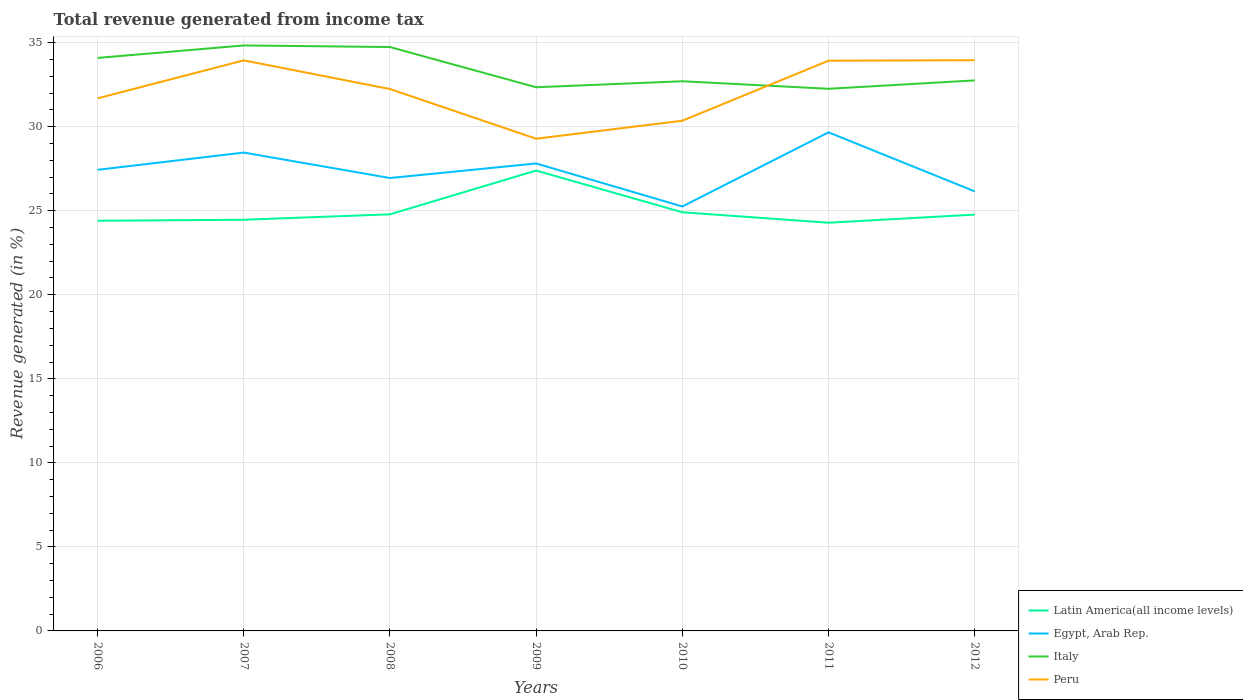Does the line corresponding to Egypt, Arab Rep. intersect with the line corresponding to Peru?
Keep it short and to the point. No. Is the number of lines equal to the number of legend labels?
Your response must be concise. Yes. Across all years, what is the maximum total revenue generated in Italy?
Your answer should be compact. 32.26. What is the total total revenue generated in Latin America(all income levels) in the graph?
Offer a terse response. -0.06. What is the difference between the highest and the second highest total revenue generated in Italy?
Offer a very short reply. 2.58. What is the difference between the highest and the lowest total revenue generated in Egypt, Arab Rep.?
Keep it short and to the point. 4. How many lines are there?
Your answer should be compact. 4. What is the difference between two consecutive major ticks on the Y-axis?
Keep it short and to the point. 5. Does the graph contain grids?
Your answer should be compact. Yes. Where does the legend appear in the graph?
Your answer should be compact. Bottom right. What is the title of the graph?
Your response must be concise. Total revenue generated from income tax. What is the label or title of the Y-axis?
Ensure brevity in your answer.  Revenue generated (in %). What is the Revenue generated (in %) of Latin America(all income levels) in 2006?
Provide a succinct answer. 24.41. What is the Revenue generated (in %) in Egypt, Arab Rep. in 2006?
Provide a short and direct response. 27.44. What is the Revenue generated (in %) in Italy in 2006?
Offer a very short reply. 34.09. What is the Revenue generated (in %) of Peru in 2006?
Your response must be concise. 31.69. What is the Revenue generated (in %) of Latin America(all income levels) in 2007?
Your answer should be very brief. 24.47. What is the Revenue generated (in %) of Egypt, Arab Rep. in 2007?
Provide a short and direct response. 28.46. What is the Revenue generated (in %) of Italy in 2007?
Provide a succinct answer. 34.84. What is the Revenue generated (in %) of Peru in 2007?
Keep it short and to the point. 33.95. What is the Revenue generated (in %) in Latin America(all income levels) in 2008?
Offer a terse response. 24.79. What is the Revenue generated (in %) in Egypt, Arab Rep. in 2008?
Provide a succinct answer. 26.95. What is the Revenue generated (in %) in Italy in 2008?
Keep it short and to the point. 34.74. What is the Revenue generated (in %) in Peru in 2008?
Offer a terse response. 32.24. What is the Revenue generated (in %) in Latin America(all income levels) in 2009?
Your response must be concise. 27.39. What is the Revenue generated (in %) in Egypt, Arab Rep. in 2009?
Give a very brief answer. 27.81. What is the Revenue generated (in %) in Italy in 2009?
Keep it short and to the point. 32.35. What is the Revenue generated (in %) of Peru in 2009?
Offer a terse response. 29.29. What is the Revenue generated (in %) of Latin America(all income levels) in 2010?
Your response must be concise. 24.91. What is the Revenue generated (in %) of Egypt, Arab Rep. in 2010?
Your answer should be compact. 25.26. What is the Revenue generated (in %) in Italy in 2010?
Provide a short and direct response. 32.71. What is the Revenue generated (in %) in Peru in 2010?
Ensure brevity in your answer.  30.36. What is the Revenue generated (in %) of Latin America(all income levels) in 2011?
Ensure brevity in your answer.  24.29. What is the Revenue generated (in %) in Egypt, Arab Rep. in 2011?
Your answer should be very brief. 29.67. What is the Revenue generated (in %) of Italy in 2011?
Keep it short and to the point. 32.26. What is the Revenue generated (in %) in Peru in 2011?
Keep it short and to the point. 33.93. What is the Revenue generated (in %) in Latin America(all income levels) in 2012?
Keep it short and to the point. 24.77. What is the Revenue generated (in %) of Egypt, Arab Rep. in 2012?
Your answer should be very brief. 26.15. What is the Revenue generated (in %) of Italy in 2012?
Keep it short and to the point. 32.76. What is the Revenue generated (in %) of Peru in 2012?
Give a very brief answer. 33.96. Across all years, what is the maximum Revenue generated (in %) of Latin America(all income levels)?
Your answer should be compact. 27.39. Across all years, what is the maximum Revenue generated (in %) in Egypt, Arab Rep.?
Your response must be concise. 29.67. Across all years, what is the maximum Revenue generated (in %) of Italy?
Provide a succinct answer. 34.84. Across all years, what is the maximum Revenue generated (in %) of Peru?
Ensure brevity in your answer.  33.96. Across all years, what is the minimum Revenue generated (in %) of Latin America(all income levels)?
Offer a terse response. 24.29. Across all years, what is the minimum Revenue generated (in %) in Egypt, Arab Rep.?
Offer a terse response. 25.26. Across all years, what is the minimum Revenue generated (in %) of Italy?
Offer a terse response. 32.26. Across all years, what is the minimum Revenue generated (in %) in Peru?
Keep it short and to the point. 29.29. What is the total Revenue generated (in %) in Latin America(all income levels) in the graph?
Provide a short and direct response. 175.02. What is the total Revenue generated (in %) in Egypt, Arab Rep. in the graph?
Offer a very short reply. 191.74. What is the total Revenue generated (in %) of Italy in the graph?
Keep it short and to the point. 233.74. What is the total Revenue generated (in %) of Peru in the graph?
Provide a succinct answer. 225.41. What is the difference between the Revenue generated (in %) of Latin America(all income levels) in 2006 and that in 2007?
Your answer should be very brief. -0.06. What is the difference between the Revenue generated (in %) of Egypt, Arab Rep. in 2006 and that in 2007?
Your answer should be very brief. -1.03. What is the difference between the Revenue generated (in %) in Italy in 2006 and that in 2007?
Keep it short and to the point. -0.74. What is the difference between the Revenue generated (in %) in Peru in 2006 and that in 2007?
Make the answer very short. -2.26. What is the difference between the Revenue generated (in %) in Latin America(all income levels) in 2006 and that in 2008?
Make the answer very short. -0.38. What is the difference between the Revenue generated (in %) in Egypt, Arab Rep. in 2006 and that in 2008?
Offer a terse response. 0.49. What is the difference between the Revenue generated (in %) in Italy in 2006 and that in 2008?
Ensure brevity in your answer.  -0.65. What is the difference between the Revenue generated (in %) in Peru in 2006 and that in 2008?
Make the answer very short. -0.55. What is the difference between the Revenue generated (in %) of Latin America(all income levels) in 2006 and that in 2009?
Give a very brief answer. -2.99. What is the difference between the Revenue generated (in %) in Egypt, Arab Rep. in 2006 and that in 2009?
Make the answer very short. -0.38. What is the difference between the Revenue generated (in %) in Italy in 2006 and that in 2009?
Your response must be concise. 1.74. What is the difference between the Revenue generated (in %) in Peru in 2006 and that in 2009?
Make the answer very short. 2.4. What is the difference between the Revenue generated (in %) of Latin America(all income levels) in 2006 and that in 2010?
Your answer should be very brief. -0.5. What is the difference between the Revenue generated (in %) in Egypt, Arab Rep. in 2006 and that in 2010?
Your answer should be compact. 2.18. What is the difference between the Revenue generated (in %) of Italy in 2006 and that in 2010?
Ensure brevity in your answer.  1.39. What is the difference between the Revenue generated (in %) of Peru in 2006 and that in 2010?
Your response must be concise. 1.33. What is the difference between the Revenue generated (in %) in Latin America(all income levels) in 2006 and that in 2011?
Ensure brevity in your answer.  0.12. What is the difference between the Revenue generated (in %) of Egypt, Arab Rep. in 2006 and that in 2011?
Your response must be concise. -2.23. What is the difference between the Revenue generated (in %) of Italy in 2006 and that in 2011?
Give a very brief answer. 1.83. What is the difference between the Revenue generated (in %) in Peru in 2006 and that in 2011?
Ensure brevity in your answer.  -2.24. What is the difference between the Revenue generated (in %) of Latin America(all income levels) in 2006 and that in 2012?
Your response must be concise. -0.37. What is the difference between the Revenue generated (in %) in Egypt, Arab Rep. in 2006 and that in 2012?
Offer a very short reply. 1.28. What is the difference between the Revenue generated (in %) in Italy in 2006 and that in 2012?
Your response must be concise. 1.34. What is the difference between the Revenue generated (in %) of Peru in 2006 and that in 2012?
Your answer should be compact. -2.27. What is the difference between the Revenue generated (in %) in Latin America(all income levels) in 2007 and that in 2008?
Your response must be concise. -0.32. What is the difference between the Revenue generated (in %) in Egypt, Arab Rep. in 2007 and that in 2008?
Your response must be concise. 1.51. What is the difference between the Revenue generated (in %) in Italy in 2007 and that in 2008?
Offer a very short reply. 0.1. What is the difference between the Revenue generated (in %) in Peru in 2007 and that in 2008?
Give a very brief answer. 1.71. What is the difference between the Revenue generated (in %) of Latin America(all income levels) in 2007 and that in 2009?
Your answer should be very brief. -2.93. What is the difference between the Revenue generated (in %) in Egypt, Arab Rep. in 2007 and that in 2009?
Offer a very short reply. 0.65. What is the difference between the Revenue generated (in %) of Italy in 2007 and that in 2009?
Offer a terse response. 2.49. What is the difference between the Revenue generated (in %) in Peru in 2007 and that in 2009?
Make the answer very short. 4.66. What is the difference between the Revenue generated (in %) of Latin America(all income levels) in 2007 and that in 2010?
Offer a terse response. -0.44. What is the difference between the Revenue generated (in %) in Egypt, Arab Rep. in 2007 and that in 2010?
Give a very brief answer. 3.21. What is the difference between the Revenue generated (in %) of Italy in 2007 and that in 2010?
Keep it short and to the point. 2.13. What is the difference between the Revenue generated (in %) in Peru in 2007 and that in 2010?
Ensure brevity in your answer.  3.59. What is the difference between the Revenue generated (in %) of Latin America(all income levels) in 2007 and that in 2011?
Make the answer very short. 0.18. What is the difference between the Revenue generated (in %) of Egypt, Arab Rep. in 2007 and that in 2011?
Give a very brief answer. -1.2. What is the difference between the Revenue generated (in %) of Italy in 2007 and that in 2011?
Provide a short and direct response. 2.58. What is the difference between the Revenue generated (in %) in Peru in 2007 and that in 2011?
Ensure brevity in your answer.  0.02. What is the difference between the Revenue generated (in %) in Latin America(all income levels) in 2007 and that in 2012?
Offer a terse response. -0.31. What is the difference between the Revenue generated (in %) of Egypt, Arab Rep. in 2007 and that in 2012?
Give a very brief answer. 2.31. What is the difference between the Revenue generated (in %) of Italy in 2007 and that in 2012?
Ensure brevity in your answer.  2.08. What is the difference between the Revenue generated (in %) in Peru in 2007 and that in 2012?
Make the answer very short. -0.01. What is the difference between the Revenue generated (in %) in Latin America(all income levels) in 2008 and that in 2009?
Keep it short and to the point. -2.61. What is the difference between the Revenue generated (in %) in Egypt, Arab Rep. in 2008 and that in 2009?
Your answer should be compact. -0.86. What is the difference between the Revenue generated (in %) of Italy in 2008 and that in 2009?
Your answer should be very brief. 2.39. What is the difference between the Revenue generated (in %) in Peru in 2008 and that in 2009?
Provide a succinct answer. 2.96. What is the difference between the Revenue generated (in %) of Latin America(all income levels) in 2008 and that in 2010?
Ensure brevity in your answer.  -0.12. What is the difference between the Revenue generated (in %) in Egypt, Arab Rep. in 2008 and that in 2010?
Your answer should be compact. 1.69. What is the difference between the Revenue generated (in %) of Italy in 2008 and that in 2010?
Give a very brief answer. 2.04. What is the difference between the Revenue generated (in %) of Peru in 2008 and that in 2010?
Offer a terse response. 1.89. What is the difference between the Revenue generated (in %) of Latin America(all income levels) in 2008 and that in 2011?
Your response must be concise. 0.5. What is the difference between the Revenue generated (in %) in Egypt, Arab Rep. in 2008 and that in 2011?
Your answer should be compact. -2.72. What is the difference between the Revenue generated (in %) of Italy in 2008 and that in 2011?
Make the answer very short. 2.48. What is the difference between the Revenue generated (in %) of Peru in 2008 and that in 2011?
Your answer should be compact. -1.69. What is the difference between the Revenue generated (in %) in Latin America(all income levels) in 2008 and that in 2012?
Provide a short and direct response. 0.02. What is the difference between the Revenue generated (in %) of Egypt, Arab Rep. in 2008 and that in 2012?
Provide a succinct answer. 0.79. What is the difference between the Revenue generated (in %) in Italy in 2008 and that in 2012?
Provide a succinct answer. 1.99. What is the difference between the Revenue generated (in %) in Peru in 2008 and that in 2012?
Your answer should be compact. -1.72. What is the difference between the Revenue generated (in %) in Latin America(all income levels) in 2009 and that in 2010?
Offer a very short reply. 2.48. What is the difference between the Revenue generated (in %) in Egypt, Arab Rep. in 2009 and that in 2010?
Provide a short and direct response. 2.56. What is the difference between the Revenue generated (in %) in Italy in 2009 and that in 2010?
Offer a very short reply. -0.36. What is the difference between the Revenue generated (in %) of Peru in 2009 and that in 2010?
Your answer should be very brief. -1.07. What is the difference between the Revenue generated (in %) of Latin America(all income levels) in 2009 and that in 2011?
Keep it short and to the point. 3.1. What is the difference between the Revenue generated (in %) of Egypt, Arab Rep. in 2009 and that in 2011?
Provide a short and direct response. -1.85. What is the difference between the Revenue generated (in %) in Italy in 2009 and that in 2011?
Offer a terse response. 0.09. What is the difference between the Revenue generated (in %) of Peru in 2009 and that in 2011?
Offer a very short reply. -4.64. What is the difference between the Revenue generated (in %) in Latin America(all income levels) in 2009 and that in 2012?
Your response must be concise. 2.62. What is the difference between the Revenue generated (in %) of Egypt, Arab Rep. in 2009 and that in 2012?
Offer a terse response. 1.66. What is the difference between the Revenue generated (in %) in Italy in 2009 and that in 2012?
Keep it short and to the point. -0.41. What is the difference between the Revenue generated (in %) in Peru in 2009 and that in 2012?
Ensure brevity in your answer.  -4.67. What is the difference between the Revenue generated (in %) of Latin America(all income levels) in 2010 and that in 2011?
Your answer should be compact. 0.62. What is the difference between the Revenue generated (in %) in Egypt, Arab Rep. in 2010 and that in 2011?
Keep it short and to the point. -4.41. What is the difference between the Revenue generated (in %) of Italy in 2010 and that in 2011?
Offer a very short reply. 0.45. What is the difference between the Revenue generated (in %) in Peru in 2010 and that in 2011?
Make the answer very short. -3.57. What is the difference between the Revenue generated (in %) of Latin America(all income levels) in 2010 and that in 2012?
Your answer should be compact. 0.14. What is the difference between the Revenue generated (in %) of Egypt, Arab Rep. in 2010 and that in 2012?
Offer a very short reply. -0.9. What is the difference between the Revenue generated (in %) in Italy in 2010 and that in 2012?
Offer a very short reply. -0.05. What is the difference between the Revenue generated (in %) in Peru in 2010 and that in 2012?
Your answer should be very brief. -3.6. What is the difference between the Revenue generated (in %) in Latin America(all income levels) in 2011 and that in 2012?
Make the answer very short. -0.48. What is the difference between the Revenue generated (in %) in Egypt, Arab Rep. in 2011 and that in 2012?
Your answer should be very brief. 3.51. What is the difference between the Revenue generated (in %) of Italy in 2011 and that in 2012?
Your answer should be compact. -0.5. What is the difference between the Revenue generated (in %) of Peru in 2011 and that in 2012?
Make the answer very short. -0.03. What is the difference between the Revenue generated (in %) of Latin America(all income levels) in 2006 and the Revenue generated (in %) of Egypt, Arab Rep. in 2007?
Provide a succinct answer. -4.06. What is the difference between the Revenue generated (in %) of Latin America(all income levels) in 2006 and the Revenue generated (in %) of Italy in 2007?
Your response must be concise. -10.43. What is the difference between the Revenue generated (in %) of Latin America(all income levels) in 2006 and the Revenue generated (in %) of Peru in 2007?
Provide a succinct answer. -9.54. What is the difference between the Revenue generated (in %) of Egypt, Arab Rep. in 2006 and the Revenue generated (in %) of Italy in 2007?
Your answer should be very brief. -7.4. What is the difference between the Revenue generated (in %) in Egypt, Arab Rep. in 2006 and the Revenue generated (in %) in Peru in 2007?
Give a very brief answer. -6.51. What is the difference between the Revenue generated (in %) in Italy in 2006 and the Revenue generated (in %) in Peru in 2007?
Make the answer very short. 0.14. What is the difference between the Revenue generated (in %) in Latin America(all income levels) in 2006 and the Revenue generated (in %) in Egypt, Arab Rep. in 2008?
Give a very brief answer. -2.54. What is the difference between the Revenue generated (in %) in Latin America(all income levels) in 2006 and the Revenue generated (in %) in Italy in 2008?
Offer a very short reply. -10.34. What is the difference between the Revenue generated (in %) of Latin America(all income levels) in 2006 and the Revenue generated (in %) of Peru in 2008?
Ensure brevity in your answer.  -7.84. What is the difference between the Revenue generated (in %) of Egypt, Arab Rep. in 2006 and the Revenue generated (in %) of Italy in 2008?
Your answer should be very brief. -7.31. What is the difference between the Revenue generated (in %) in Egypt, Arab Rep. in 2006 and the Revenue generated (in %) in Peru in 2008?
Make the answer very short. -4.81. What is the difference between the Revenue generated (in %) of Italy in 2006 and the Revenue generated (in %) of Peru in 2008?
Offer a terse response. 1.85. What is the difference between the Revenue generated (in %) of Latin America(all income levels) in 2006 and the Revenue generated (in %) of Egypt, Arab Rep. in 2009?
Offer a very short reply. -3.41. What is the difference between the Revenue generated (in %) of Latin America(all income levels) in 2006 and the Revenue generated (in %) of Italy in 2009?
Ensure brevity in your answer.  -7.94. What is the difference between the Revenue generated (in %) in Latin America(all income levels) in 2006 and the Revenue generated (in %) in Peru in 2009?
Ensure brevity in your answer.  -4.88. What is the difference between the Revenue generated (in %) in Egypt, Arab Rep. in 2006 and the Revenue generated (in %) in Italy in 2009?
Your response must be concise. -4.91. What is the difference between the Revenue generated (in %) of Egypt, Arab Rep. in 2006 and the Revenue generated (in %) of Peru in 2009?
Ensure brevity in your answer.  -1.85. What is the difference between the Revenue generated (in %) of Italy in 2006 and the Revenue generated (in %) of Peru in 2009?
Offer a terse response. 4.81. What is the difference between the Revenue generated (in %) of Latin America(all income levels) in 2006 and the Revenue generated (in %) of Egypt, Arab Rep. in 2010?
Offer a very short reply. -0.85. What is the difference between the Revenue generated (in %) of Latin America(all income levels) in 2006 and the Revenue generated (in %) of Peru in 2010?
Give a very brief answer. -5.95. What is the difference between the Revenue generated (in %) in Egypt, Arab Rep. in 2006 and the Revenue generated (in %) in Italy in 2010?
Provide a short and direct response. -5.27. What is the difference between the Revenue generated (in %) in Egypt, Arab Rep. in 2006 and the Revenue generated (in %) in Peru in 2010?
Your answer should be compact. -2.92. What is the difference between the Revenue generated (in %) of Italy in 2006 and the Revenue generated (in %) of Peru in 2010?
Keep it short and to the point. 3.74. What is the difference between the Revenue generated (in %) of Latin America(all income levels) in 2006 and the Revenue generated (in %) of Egypt, Arab Rep. in 2011?
Ensure brevity in your answer.  -5.26. What is the difference between the Revenue generated (in %) in Latin America(all income levels) in 2006 and the Revenue generated (in %) in Italy in 2011?
Offer a terse response. -7.85. What is the difference between the Revenue generated (in %) of Latin America(all income levels) in 2006 and the Revenue generated (in %) of Peru in 2011?
Your answer should be very brief. -9.52. What is the difference between the Revenue generated (in %) of Egypt, Arab Rep. in 2006 and the Revenue generated (in %) of Italy in 2011?
Provide a short and direct response. -4.82. What is the difference between the Revenue generated (in %) of Egypt, Arab Rep. in 2006 and the Revenue generated (in %) of Peru in 2011?
Your answer should be compact. -6.49. What is the difference between the Revenue generated (in %) of Italy in 2006 and the Revenue generated (in %) of Peru in 2011?
Keep it short and to the point. 0.16. What is the difference between the Revenue generated (in %) of Latin America(all income levels) in 2006 and the Revenue generated (in %) of Egypt, Arab Rep. in 2012?
Make the answer very short. -1.75. What is the difference between the Revenue generated (in %) in Latin America(all income levels) in 2006 and the Revenue generated (in %) in Italy in 2012?
Your answer should be compact. -8.35. What is the difference between the Revenue generated (in %) of Latin America(all income levels) in 2006 and the Revenue generated (in %) of Peru in 2012?
Your answer should be compact. -9.55. What is the difference between the Revenue generated (in %) in Egypt, Arab Rep. in 2006 and the Revenue generated (in %) in Italy in 2012?
Ensure brevity in your answer.  -5.32. What is the difference between the Revenue generated (in %) in Egypt, Arab Rep. in 2006 and the Revenue generated (in %) in Peru in 2012?
Offer a terse response. -6.52. What is the difference between the Revenue generated (in %) in Italy in 2006 and the Revenue generated (in %) in Peru in 2012?
Provide a short and direct response. 0.13. What is the difference between the Revenue generated (in %) in Latin America(all income levels) in 2007 and the Revenue generated (in %) in Egypt, Arab Rep. in 2008?
Give a very brief answer. -2.48. What is the difference between the Revenue generated (in %) of Latin America(all income levels) in 2007 and the Revenue generated (in %) of Italy in 2008?
Give a very brief answer. -10.28. What is the difference between the Revenue generated (in %) of Latin America(all income levels) in 2007 and the Revenue generated (in %) of Peru in 2008?
Provide a succinct answer. -7.78. What is the difference between the Revenue generated (in %) of Egypt, Arab Rep. in 2007 and the Revenue generated (in %) of Italy in 2008?
Make the answer very short. -6.28. What is the difference between the Revenue generated (in %) in Egypt, Arab Rep. in 2007 and the Revenue generated (in %) in Peru in 2008?
Your answer should be compact. -3.78. What is the difference between the Revenue generated (in %) in Italy in 2007 and the Revenue generated (in %) in Peru in 2008?
Provide a succinct answer. 2.59. What is the difference between the Revenue generated (in %) in Latin America(all income levels) in 2007 and the Revenue generated (in %) in Egypt, Arab Rep. in 2009?
Your response must be concise. -3.35. What is the difference between the Revenue generated (in %) of Latin America(all income levels) in 2007 and the Revenue generated (in %) of Italy in 2009?
Provide a succinct answer. -7.88. What is the difference between the Revenue generated (in %) of Latin America(all income levels) in 2007 and the Revenue generated (in %) of Peru in 2009?
Offer a very short reply. -4.82. What is the difference between the Revenue generated (in %) of Egypt, Arab Rep. in 2007 and the Revenue generated (in %) of Italy in 2009?
Offer a very short reply. -3.89. What is the difference between the Revenue generated (in %) in Egypt, Arab Rep. in 2007 and the Revenue generated (in %) in Peru in 2009?
Provide a succinct answer. -0.82. What is the difference between the Revenue generated (in %) of Italy in 2007 and the Revenue generated (in %) of Peru in 2009?
Your response must be concise. 5.55. What is the difference between the Revenue generated (in %) in Latin America(all income levels) in 2007 and the Revenue generated (in %) in Egypt, Arab Rep. in 2010?
Provide a short and direct response. -0.79. What is the difference between the Revenue generated (in %) in Latin America(all income levels) in 2007 and the Revenue generated (in %) in Italy in 2010?
Make the answer very short. -8.24. What is the difference between the Revenue generated (in %) in Latin America(all income levels) in 2007 and the Revenue generated (in %) in Peru in 2010?
Provide a succinct answer. -5.89. What is the difference between the Revenue generated (in %) of Egypt, Arab Rep. in 2007 and the Revenue generated (in %) of Italy in 2010?
Your answer should be compact. -4.24. What is the difference between the Revenue generated (in %) of Egypt, Arab Rep. in 2007 and the Revenue generated (in %) of Peru in 2010?
Provide a succinct answer. -1.89. What is the difference between the Revenue generated (in %) in Italy in 2007 and the Revenue generated (in %) in Peru in 2010?
Keep it short and to the point. 4.48. What is the difference between the Revenue generated (in %) in Latin America(all income levels) in 2007 and the Revenue generated (in %) in Egypt, Arab Rep. in 2011?
Offer a terse response. -5.2. What is the difference between the Revenue generated (in %) of Latin America(all income levels) in 2007 and the Revenue generated (in %) of Italy in 2011?
Your answer should be very brief. -7.79. What is the difference between the Revenue generated (in %) in Latin America(all income levels) in 2007 and the Revenue generated (in %) in Peru in 2011?
Offer a terse response. -9.46. What is the difference between the Revenue generated (in %) of Egypt, Arab Rep. in 2007 and the Revenue generated (in %) of Italy in 2011?
Offer a terse response. -3.8. What is the difference between the Revenue generated (in %) in Egypt, Arab Rep. in 2007 and the Revenue generated (in %) in Peru in 2011?
Make the answer very short. -5.47. What is the difference between the Revenue generated (in %) in Italy in 2007 and the Revenue generated (in %) in Peru in 2011?
Keep it short and to the point. 0.91. What is the difference between the Revenue generated (in %) in Latin America(all income levels) in 2007 and the Revenue generated (in %) in Egypt, Arab Rep. in 2012?
Your answer should be compact. -1.69. What is the difference between the Revenue generated (in %) in Latin America(all income levels) in 2007 and the Revenue generated (in %) in Italy in 2012?
Offer a very short reply. -8.29. What is the difference between the Revenue generated (in %) of Latin America(all income levels) in 2007 and the Revenue generated (in %) of Peru in 2012?
Your response must be concise. -9.49. What is the difference between the Revenue generated (in %) of Egypt, Arab Rep. in 2007 and the Revenue generated (in %) of Italy in 2012?
Offer a terse response. -4.29. What is the difference between the Revenue generated (in %) of Egypt, Arab Rep. in 2007 and the Revenue generated (in %) of Peru in 2012?
Your response must be concise. -5.5. What is the difference between the Revenue generated (in %) in Italy in 2007 and the Revenue generated (in %) in Peru in 2012?
Provide a succinct answer. 0.88. What is the difference between the Revenue generated (in %) of Latin America(all income levels) in 2008 and the Revenue generated (in %) of Egypt, Arab Rep. in 2009?
Provide a succinct answer. -3.03. What is the difference between the Revenue generated (in %) of Latin America(all income levels) in 2008 and the Revenue generated (in %) of Italy in 2009?
Your answer should be compact. -7.56. What is the difference between the Revenue generated (in %) of Latin America(all income levels) in 2008 and the Revenue generated (in %) of Peru in 2009?
Offer a terse response. -4.5. What is the difference between the Revenue generated (in %) in Egypt, Arab Rep. in 2008 and the Revenue generated (in %) in Peru in 2009?
Ensure brevity in your answer.  -2.34. What is the difference between the Revenue generated (in %) in Italy in 2008 and the Revenue generated (in %) in Peru in 2009?
Keep it short and to the point. 5.46. What is the difference between the Revenue generated (in %) in Latin America(all income levels) in 2008 and the Revenue generated (in %) in Egypt, Arab Rep. in 2010?
Keep it short and to the point. -0.47. What is the difference between the Revenue generated (in %) of Latin America(all income levels) in 2008 and the Revenue generated (in %) of Italy in 2010?
Provide a short and direct response. -7.92. What is the difference between the Revenue generated (in %) of Latin America(all income levels) in 2008 and the Revenue generated (in %) of Peru in 2010?
Offer a very short reply. -5.57. What is the difference between the Revenue generated (in %) of Egypt, Arab Rep. in 2008 and the Revenue generated (in %) of Italy in 2010?
Provide a succinct answer. -5.76. What is the difference between the Revenue generated (in %) of Egypt, Arab Rep. in 2008 and the Revenue generated (in %) of Peru in 2010?
Offer a terse response. -3.41. What is the difference between the Revenue generated (in %) in Italy in 2008 and the Revenue generated (in %) in Peru in 2010?
Your response must be concise. 4.38. What is the difference between the Revenue generated (in %) of Latin America(all income levels) in 2008 and the Revenue generated (in %) of Egypt, Arab Rep. in 2011?
Offer a terse response. -4.88. What is the difference between the Revenue generated (in %) in Latin America(all income levels) in 2008 and the Revenue generated (in %) in Italy in 2011?
Make the answer very short. -7.47. What is the difference between the Revenue generated (in %) of Latin America(all income levels) in 2008 and the Revenue generated (in %) of Peru in 2011?
Make the answer very short. -9.14. What is the difference between the Revenue generated (in %) of Egypt, Arab Rep. in 2008 and the Revenue generated (in %) of Italy in 2011?
Offer a terse response. -5.31. What is the difference between the Revenue generated (in %) in Egypt, Arab Rep. in 2008 and the Revenue generated (in %) in Peru in 2011?
Your answer should be very brief. -6.98. What is the difference between the Revenue generated (in %) of Italy in 2008 and the Revenue generated (in %) of Peru in 2011?
Your answer should be very brief. 0.81. What is the difference between the Revenue generated (in %) in Latin America(all income levels) in 2008 and the Revenue generated (in %) in Egypt, Arab Rep. in 2012?
Provide a succinct answer. -1.37. What is the difference between the Revenue generated (in %) in Latin America(all income levels) in 2008 and the Revenue generated (in %) in Italy in 2012?
Keep it short and to the point. -7.97. What is the difference between the Revenue generated (in %) in Latin America(all income levels) in 2008 and the Revenue generated (in %) in Peru in 2012?
Offer a very short reply. -9.17. What is the difference between the Revenue generated (in %) of Egypt, Arab Rep. in 2008 and the Revenue generated (in %) of Italy in 2012?
Give a very brief answer. -5.81. What is the difference between the Revenue generated (in %) in Egypt, Arab Rep. in 2008 and the Revenue generated (in %) in Peru in 2012?
Offer a very short reply. -7.01. What is the difference between the Revenue generated (in %) in Italy in 2008 and the Revenue generated (in %) in Peru in 2012?
Ensure brevity in your answer.  0.78. What is the difference between the Revenue generated (in %) of Latin America(all income levels) in 2009 and the Revenue generated (in %) of Egypt, Arab Rep. in 2010?
Offer a very short reply. 2.14. What is the difference between the Revenue generated (in %) of Latin America(all income levels) in 2009 and the Revenue generated (in %) of Italy in 2010?
Your answer should be very brief. -5.31. What is the difference between the Revenue generated (in %) of Latin America(all income levels) in 2009 and the Revenue generated (in %) of Peru in 2010?
Your answer should be compact. -2.96. What is the difference between the Revenue generated (in %) in Egypt, Arab Rep. in 2009 and the Revenue generated (in %) in Italy in 2010?
Offer a very short reply. -4.89. What is the difference between the Revenue generated (in %) of Egypt, Arab Rep. in 2009 and the Revenue generated (in %) of Peru in 2010?
Your answer should be very brief. -2.54. What is the difference between the Revenue generated (in %) of Italy in 2009 and the Revenue generated (in %) of Peru in 2010?
Provide a succinct answer. 1.99. What is the difference between the Revenue generated (in %) in Latin America(all income levels) in 2009 and the Revenue generated (in %) in Egypt, Arab Rep. in 2011?
Provide a short and direct response. -2.27. What is the difference between the Revenue generated (in %) of Latin America(all income levels) in 2009 and the Revenue generated (in %) of Italy in 2011?
Your response must be concise. -4.87. What is the difference between the Revenue generated (in %) of Latin America(all income levels) in 2009 and the Revenue generated (in %) of Peru in 2011?
Your answer should be compact. -6.54. What is the difference between the Revenue generated (in %) of Egypt, Arab Rep. in 2009 and the Revenue generated (in %) of Italy in 2011?
Offer a very short reply. -4.44. What is the difference between the Revenue generated (in %) in Egypt, Arab Rep. in 2009 and the Revenue generated (in %) in Peru in 2011?
Your answer should be very brief. -6.12. What is the difference between the Revenue generated (in %) of Italy in 2009 and the Revenue generated (in %) of Peru in 2011?
Your answer should be very brief. -1.58. What is the difference between the Revenue generated (in %) of Latin America(all income levels) in 2009 and the Revenue generated (in %) of Egypt, Arab Rep. in 2012?
Provide a succinct answer. 1.24. What is the difference between the Revenue generated (in %) of Latin America(all income levels) in 2009 and the Revenue generated (in %) of Italy in 2012?
Offer a terse response. -5.36. What is the difference between the Revenue generated (in %) of Latin America(all income levels) in 2009 and the Revenue generated (in %) of Peru in 2012?
Make the answer very short. -6.57. What is the difference between the Revenue generated (in %) in Egypt, Arab Rep. in 2009 and the Revenue generated (in %) in Italy in 2012?
Offer a very short reply. -4.94. What is the difference between the Revenue generated (in %) in Egypt, Arab Rep. in 2009 and the Revenue generated (in %) in Peru in 2012?
Keep it short and to the point. -6.15. What is the difference between the Revenue generated (in %) of Italy in 2009 and the Revenue generated (in %) of Peru in 2012?
Your answer should be compact. -1.61. What is the difference between the Revenue generated (in %) in Latin America(all income levels) in 2010 and the Revenue generated (in %) in Egypt, Arab Rep. in 2011?
Offer a very short reply. -4.76. What is the difference between the Revenue generated (in %) in Latin America(all income levels) in 2010 and the Revenue generated (in %) in Italy in 2011?
Give a very brief answer. -7.35. What is the difference between the Revenue generated (in %) of Latin America(all income levels) in 2010 and the Revenue generated (in %) of Peru in 2011?
Your answer should be very brief. -9.02. What is the difference between the Revenue generated (in %) of Egypt, Arab Rep. in 2010 and the Revenue generated (in %) of Italy in 2011?
Your response must be concise. -7. What is the difference between the Revenue generated (in %) in Egypt, Arab Rep. in 2010 and the Revenue generated (in %) in Peru in 2011?
Provide a succinct answer. -8.67. What is the difference between the Revenue generated (in %) in Italy in 2010 and the Revenue generated (in %) in Peru in 2011?
Your answer should be compact. -1.22. What is the difference between the Revenue generated (in %) of Latin America(all income levels) in 2010 and the Revenue generated (in %) of Egypt, Arab Rep. in 2012?
Ensure brevity in your answer.  -1.24. What is the difference between the Revenue generated (in %) in Latin America(all income levels) in 2010 and the Revenue generated (in %) in Italy in 2012?
Your answer should be compact. -7.85. What is the difference between the Revenue generated (in %) of Latin America(all income levels) in 2010 and the Revenue generated (in %) of Peru in 2012?
Your response must be concise. -9.05. What is the difference between the Revenue generated (in %) of Egypt, Arab Rep. in 2010 and the Revenue generated (in %) of Italy in 2012?
Keep it short and to the point. -7.5. What is the difference between the Revenue generated (in %) of Egypt, Arab Rep. in 2010 and the Revenue generated (in %) of Peru in 2012?
Make the answer very short. -8.7. What is the difference between the Revenue generated (in %) in Italy in 2010 and the Revenue generated (in %) in Peru in 2012?
Offer a very short reply. -1.25. What is the difference between the Revenue generated (in %) of Latin America(all income levels) in 2011 and the Revenue generated (in %) of Egypt, Arab Rep. in 2012?
Your response must be concise. -1.87. What is the difference between the Revenue generated (in %) of Latin America(all income levels) in 2011 and the Revenue generated (in %) of Italy in 2012?
Your answer should be compact. -8.47. What is the difference between the Revenue generated (in %) in Latin America(all income levels) in 2011 and the Revenue generated (in %) in Peru in 2012?
Your answer should be very brief. -9.67. What is the difference between the Revenue generated (in %) of Egypt, Arab Rep. in 2011 and the Revenue generated (in %) of Italy in 2012?
Offer a terse response. -3.09. What is the difference between the Revenue generated (in %) in Egypt, Arab Rep. in 2011 and the Revenue generated (in %) in Peru in 2012?
Offer a very short reply. -4.29. What is the difference between the Revenue generated (in %) of Italy in 2011 and the Revenue generated (in %) of Peru in 2012?
Ensure brevity in your answer.  -1.7. What is the average Revenue generated (in %) in Latin America(all income levels) per year?
Make the answer very short. 25. What is the average Revenue generated (in %) of Egypt, Arab Rep. per year?
Offer a very short reply. 27.39. What is the average Revenue generated (in %) of Italy per year?
Offer a terse response. 33.39. What is the average Revenue generated (in %) in Peru per year?
Provide a succinct answer. 32.2. In the year 2006, what is the difference between the Revenue generated (in %) in Latin America(all income levels) and Revenue generated (in %) in Egypt, Arab Rep.?
Give a very brief answer. -3.03. In the year 2006, what is the difference between the Revenue generated (in %) of Latin America(all income levels) and Revenue generated (in %) of Italy?
Your answer should be very brief. -9.69. In the year 2006, what is the difference between the Revenue generated (in %) in Latin America(all income levels) and Revenue generated (in %) in Peru?
Offer a very short reply. -7.28. In the year 2006, what is the difference between the Revenue generated (in %) of Egypt, Arab Rep. and Revenue generated (in %) of Italy?
Your response must be concise. -6.66. In the year 2006, what is the difference between the Revenue generated (in %) of Egypt, Arab Rep. and Revenue generated (in %) of Peru?
Provide a short and direct response. -4.25. In the year 2006, what is the difference between the Revenue generated (in %) of Italy and Revenue generated (in %) of Peru?
Give a very brief answer. 2.4. In the year 2007, what is the difference between the Revenue generated (in %) of Latin America(all income levels) and Revenue generated (in %) of Egypt, Arab Rep.?
Provide a short and direct response. -4. In the year 2007, what is the difference between the Revenue generated (in %) in Latin America(all income levels) and Revenue generated (in %) in Italy?
Offer a very short reply. -10.37. In the year 2007, what is the difference between the Revenue generated (in %) in Latin America(all income levels) and Revenue generated (in %) in Peru?
Provide a succinct answer. -9.48. In the year 2007, what is the difference between the Revenue generated (in %) in Egypt, Arab Rep. and Revenue generated (in %) in Italy?
Offer a very short reply. -6.37. In the year 2007, what is the difference between the Revenue generated (in %) of Egypt, Arab Rep. and Revenue generated (in %) of Peru?
Give a very brief answer. -5.49. In the year 2007, what is the difference between the Revenue generated (in %) of Italy and Revenue generated (in %) of Peru?
Provide a succinct answer. 0.89. In the year 2008, what is the difference between the Revenue generated (in %) of Latin America(all income levels) and Revenue generated (in %) of Egypt, Arab Rep.?
Provide a succinct answer. -2.16. In the year 2008, what is the difference between the Revenue generated (in %) of Latin America(all income levels) and Revenue generated (in %) of Italy?
Provide a short and direct response. -9.95. In the year 2008, what is the difference between the Revenue generated (in %) of Latin America(all income levels) and Revenue generated (in %) of Peru?
Offer a terse response. -7.46. In the year 2008, what is the difference between the Revenue generated (in %) of Egypt, Arab Rep. and Revenue generated (in %) of Italy?
Offer a very short reply. -7.79. In the year 2008, what is the difference between the Revenue generated (in %) of Egypt, Arab Rep. and Revenue generated (in %) of Peru?
Ensure brevity in your answer.  -5.29. In the year 2008, what is the difference between the Revenue generated (in %) of Italy and Revenue generated (in %) of Peru?
Offer a very short reply. 2.5. In the year 2009, what is the difference between the Revenue generated (in %) in Latin America(all income levels) and Revenue generated (in %) in Egypt, Arab Rep.?
Offer a very short reply. -0.42. In the year 2009, what is the difference between the Revenue generated (in %) of Latin America(all income levels) and Revenue generated (in %) of Italy?
Ensure brevity in your answer.  -4.96. In the year 2009, what is the difference between the Revenue generated (in %) of Latin America(all income levels) and Revenue generated (in %) of Peru?
Provide a short and direct response. -1.89. In the year 2009, what is the difference between the Revenue generated (in %) of Egypt, Arab Rep. and Revenue generated (in %) of Italy?
Ensure brevity in your answer.  -4.54. In the year 2009, what is the difference between the Revenue generated (in %) in Egypt, Arab Rep. and Revenue generated (in %) in Peru?
Keep it short and to the point. -1.47. In the year 2009, what is the difference between the Revenue generated (in %) in Italy and Revenue generated (in %) in Peru?
Your response must be concise. 3.06. In the year 2010, what is the difference between the Revenue generated (in %) in Latin America(all income levels) and Revenue generated (in %) in Egypt, Arab Rep.?
Provide a short and direct response. -0.34. In the year 2010, what is the difference between the Revenue generated (in %) in Latin America(all income levels) and Revenue generated (in %) in Italy?
Offer a very short reply. -7.8. In the year 2010, what is the difference between the Revenue generated (in %) in Latin America(all income levels) and Revenue generated (in %) in Peru?
Provide a succinct answer. -5.45. In the year 2010, what is the difference between the Revenue generated (in %) in Egypt, Arab Rep. and Revenue generated (in %) in Italy?
Your response must be concise. -7.45. In the year 2010, what is the difference between the Revenue generated (in %) in Egypt, Arab Rep. and Revenue generated (in %) in Peru?
Your answer should be compact. -5.1. In the year 2010, what is the difference between the Revenue generated (in %) in Italy and Revenue generated (in %) in Peru?
Provide a short and direct response. 2.35. In the year 2011, what is the difference between the Revenue generated (in %) of Latin America(all income levels) and Revenue generated (in %) of Egypt, Arab Rep.?
Provide a succinct answer. -5.38. In the year 2011, what is the difference between the Revenue generated (in %) of Latin America(all income levels) and Revenue generated (in %) of Italy?
Your response must be concise. -7.97. In the year 2011, what is the difference between the Revenue generated (in %) in Latin America(all income levels) and Revenue generated (in %) in Peru?
Your response must be concise. -9.64. In the year 2011, what is the difference between the Revenue generated (in %) of Egypt, Arab Rep. and Revenue generated (in %) of Italy?
Provide a short and direct response. -2.59. In the year 2011, what is the difference between the Revenue generated (in %) in Egypt, Arab Rep. and Revenue generated (in %) in Peru?
Your answer should be compact. -4.26. In the year 2011, what is the difference between the Revenue generated (in %) in Italy and Revenue generated (in %) in Peru?
Your response must be concise. -1.67. In the year 2012, what is the difference between the Revenue generated (in %) of Latin America(all income levels) and Revenue generated (in %) of Egypt, Arab Rep.?
Your response must be concise. -1.38. In the year 2012, what is the difference between the Revenue generated (in %) of Latin America(all income levels) and Revenue generated (in %) of Italy?
Provide a succinct answer. -7.99. In the year 2012, what is the difference between the Revenue generated (in %) of Latin America(all income levels) and Revenue generated (in %) of Peru?
Keep it short and to the point. -9.19. In the year 2012, what is the difference between the Revenue generated (in %) in Egypt, Arab Rep. and Revenue generated (in %) in Italy?
Ensure brevity in your answer.  -6.6. In the year 2012, what is the difference between the Revenue generated (in %) in Egypt, Arab Rep. and Revenue generated (in %) in Peru?
Your answer should be very brief. -7.8. In the year 2012, what is the difference between the Revenue generated (in %) of Italy and Revenue generated (in %) of Peru?
Keep it short and to the point. -1.2. What is the ratio of the Revenue generated (in %) of Egypt, Arab Rep. in 2006 to that in 2007?
Offer a very short reply. 0.96. What is the ratio of the Revenue generated (in %) of Italy in 2006 to that in 2007?
Your answer should be very brief. 0.98. What is the ratio of the Revenue generated (in %) of Peru in 2006 to that in 2007?
Give a very brief answer. 0.93. What is the ratio of the Revenue generated (in %) of Latin America(all income levels) in 2006 to that in 2008?
Offer a very short reply. 0.98. What is the ratio of the Revenue generated (in %) in Egypt, Arab Rep. in 2006 to that in 2008?
Offer a very short reply. 1.02. What is the ratio of the Revenue generated (in %) in Italy in 2006 to that in 2008?
Your answer should be very brief. 0.98. What is the ratio of the Revenue generated (in %) of Peru in 2006 to that in 2008?
Offer a terse response. 0.98. What is the ratio of the Revenue generated (in %) of Latin America(all income levels) in 2006 to that in 2009?
Make the answer very short. 0.89. What is the ratio of the Revenue generated (in %) of Egypt, Arab Rep. in 2006 to that in 2009?
Offer a very short reply. 0.99. What is the ratio of the Revenue generated (in %) of Italy in 2006 to that in 2009?
Your answer should be compact. 1.05. What is the ratio of the Revenue generated (in %) of Peru in 2006 to that in 2009?
Give a very brief answer. 1.08. What is the ratio of the Revenue generated (in %) of Latin America(all income levels) in 2006 to that in 2010?
Ensure brevity in your answer.  0.98. What is the ratio of the Revenue generated (in %) of Egypt, Arab Rep. in 2006 to that in 2010?
Offer a terse response. 1.09. What is the ratio of the Revenue generated (in %) of Italy in 2006 to that in 2010?
Make the answer very short. 1.04. What is the ratio of the Revenue generated (in %) in Peru in 2006 to that in 2010?
Offer a terse response. 1.04. What is the ratio of the Revenue generated (in %) of Egypt, Arab Rep. in 2006 to that in 2011?
Ensure brevity in your answer.  0.92. What is the ratio of the Revenue generated (in %) in Italy in 2006 to that in 2011?
Your response must be concise. 1.06. What is the ratio of the Revenue generated (in %) in Peru in 2006 to that in 2011?
Give a very brief answer. 0.93. What is the ratio of the Revenue generated (in %) in Latin America(all income levels) in 2006 to that in 2012?
Offer a very short reply. 0.99. What is the ratio of the Revenue generated (in %) of Egypt, Arab Rep. in 2006 to that in 2012?
Ensure brevity in your answer.  1.05. What is the ratio of the Revenue generated (in %) of Italy in 2006 to that in 2012?
Offer a terse response. 1.04. What is the ratio of the Revenue generated (in %) of Peru in 2006 to that in 2012?
Make the answer very short. 0.93. What is the ratio of the Revenue generated (in %) in Egypt, Arab Rep. in 2007 to that in 2008?
Ensure brevity in your answer.  1.06. What is the ratio of the Revenue generated (in %) of Peru in 2007 to that in 2008?
Make the answer very short. 1.05. What is the ratio of the Revenue generated (in %) in Latin America(all income levels) in 2007 to that in 2009?
Make the answer very short. 0.89. What is the ratio of the Revenue generated (in %) in Egypt, Arab Rep. in 2007 to that in 2009?
Make the answer very short. 1.02. What is the ratio of the Revenue generated (in %) in Peru in 2007 to that in 2009?
Provide a succinct answer. 1.16. What is the ratio of the Revenue generated (in %) of Latin America(all income levels) in 2007 to that in 2010?
Offer a very short reply. 0.98. What is the ratio of the Revenue generated (in %) of Egypt, Arab Rep. in 2007 to that in 2010?
Make the answer very short. 1.13. What is the ratio of the Revenue generated (in %) in Italy in 2007 to that in 2010?
Provide a succinct answer. 1.07. What is the ratio of the Revenue generated (in %) in Peru in 2007 to that in 2010?
Your answer should be compact. 1.12. What is the ratio of the Revenue generated (in %) of Latin America(all income levels) in 2007 to that in 2011?
Keep it short and to the point. 1.01. What is the ratio of the Revenue generated (in %) of Egypt, Arab Rep. in 2007 to that in 2011?
Keep it short and to the point. 0.96. What is the ratio of the Revenue generated (in %) in Italy in 2007 to that in 2011?
Provide a succinct answer. 1.08. What is the ratio of the Revenue generated (in %) of Latin America(all income levels) in 2007 to that in 2012?
Your response must be concise. 0.99. What is the ratio of the Revenue generated (in %) in Egypt, Arab Rep. in 2007 to that in 2012?
Your answer should be compact. 1.09. What is the ratio of the Revenue generated (in %) in Italy in 2007 to that in 2012?
Your response must be concise. 1.06. What is the ratio of the Revenue generated (in %) of Latin America(all income levels) in 2008 to that in 2009?
Offer a very short reply. 0.9. What is the ratio of the Revenue generated (in %) of Egypt, Arab Rep. in 2008 to that in 2009?
Provide a short and direct response. 0.97. What is the ratio of the Revenue generated (in %) of Italy in 2008 to that in 2009?
Provide a succinct answer. 1.07. What is the ratio of the Revenue generated (in %) of Peru in 2008 to that in 2009?
Ensure brevity in your answer.  1.1. What is the ratio of the Revenue generated (in %) of Egypt, Arab Rep. in 2008 to that in 2010?
Offer a very short reply. 1.07. What is the ratio of the Revenue generated (in %) in Italy in 2008 to that in 2010?
Ensure brevity in your answer.  1.06. What is the ratio of the Revenue generated (in %) in Peru in 2008 to that in 2010?
Make the answer very short. 1.06. What is the ratio of the Revenue generated (in %) in Latin America(all income levels) in 2008 to that in 2011?
Keep it short and to the point. 1.02. What is the ratio of the Revenue generated (in %) in Egypt, Arab Rep. in 2008 to that in 2011?
Provide a short and direct response. 0.91. What is the ratio of the Revenue generated (in %) in Italy in 2008 to that in 2011?
Keep it short and to the point. 1.08. What is the ratio of the Revenue generated (in %) of Peru in 2008 to that in 2011?
Your response must be concise. 0.95. What is the ratio of the Revenue generated (in %) in Egypt, Arab Rep. in 2008 to that in 2012?
Your answer should be compact. 1.03. What is the ratio of the Revenue generated (in %) of Italy in 2008 to that in 2012?
Your answer should be compact. 1.06. What is the ratio of the Revenue generated (in %) in Peru in 2008 to that in 2012?
Your answer should be very brief. 0.95. What is the ratio of the Revenue generated (in %) in Latin America(all income levels) in 2009 to that in 2010?
Keep it short and to the point. 1.1. What is the ratio of the Revenue generated (in %) of Egypt, Arab Rep. in 2009 to that in 2010?
Offer a terse response. 1.1. What is the ratio of the Revenue generated (in %) in Italy in 2009 to that in 2010?
Keep it short and to the point. 0.99. What is the ratio of the Revenue generated (in %) in Peru in 2009 to that in 2010?
Your answer should be very brief. 0.96. What is the ratio of the Revenue generated (in %) in Latin America(all income levels) in 2009 to that in 2011?
Offer a terse response. 1.13. What is the ratio of the Revenue generated (in %) in Egypt, Arab Rep. in 2009 to that in 2011?
Your answer should be very brief. 0.94. What is the ratio of the Revenue generated (in %) of Italy in 2009 to that in 2011?
Give a very brief answer. 1. What is the ratio of the Revenue generated (in %) in Peru in 2009 to that in 2011?
Your answer should be very brief. 0.86. What is the ratio of the Revenue generated (in %) in Latin America(all income levels) in 2009 to that in 2012?
Offer a terse response. 1.11. What is the ratio of the Revenue generated (in %) of Egypt, Arab Rep. in 2009 to that in 2012?
Your response must be concise. 1.06. What is the ratio of the Revenue generated (in %) in Italy in 2009 to that in 2012?
Your answer should be very brief. 0.99. What is the ratio of the Revenue generated (in %) of Peru in 2009 to that in 2012?
Your answer should be compact. 0.86. What is the ratio of the Revenue generated (in %) in Latin America(all income levels) in 2010 to that in 2011?
Provide a short and direct response. 1.03. What is the ratio of the Revenue generated (in %) in Egypt, Arab Rep. in 2010 to that in 2011?
Keep it short and to the point. 0.85. What is the ratio of the Revenue generated (in %) in Italy in 2010 to that in 2011?
Give a very brief answer. 1.01. What is the ratio of the Revenue generated (in %) in Peru in 2010 to that in 2011?
Make the answer very short. 0.89. What is the ratio of the Revenue generated (in %) of Latin America(all income levels) in 2010 to that in 2012?
Offer a terse response. 1.01. What is the ratio of the Revenue generated (in %) in Egypt, Arab Rep. in 2010 to that in 2012?
Provide a short and direct response. 0.97. What is the ratio of the Revenue generated (in %) of Peru in 2010 to that in 2012?
Provide a short and direct response. 0.89. What is the ratio of the Revenue generated (in %) in Latin America(all income levels) in 2011 to that in 2012?
Provide a succinct answer. 0.98. What is the ratio of the Revenue generated (in %) of Egypt, Arab Rep. in 2011 to that in 2012?
Offer a very short reply. 1.13. What is the ratio of the Revenue generated (in %) in Peru in 2011 to that in 2012?
Offer a very short reply. 1. What is the difference between the highest and the second highest Revenue generated (in %) of Latin America(all income levels)?
Your answer should be compact. 2.48. What is the difference between the highest and the second highest Revenue generated (in %) of Egypt, Arab Rep.?
Your answer should be compact. 1.2. What is the difference between the highest and the second highest Revenue generated (in %) in Italy?
Give a very brief answer. 0.1. What is the difference between the highest and the second highest Revenue generated (in %) of Peru?
Provide a short and direct response. 0.01. What is the difference between the highest and the lowest Revenue generated (in %) of Latin America(all income levels)?
Provide a succinct answer. 3.1. What is the difference between the highest and the lowest Revenue generated (in %) of Egypt, Arab Rep.?
Provide a succinct answer. 4.41. What is the difference between the highest and the lowest Revenue generated (in %) of Italy?
Offer a very short reply. 2.58. What is the difference between the highest and the lowest Revenue generated (in %) of Peru?
Your answer should be very brief. 4.67. 